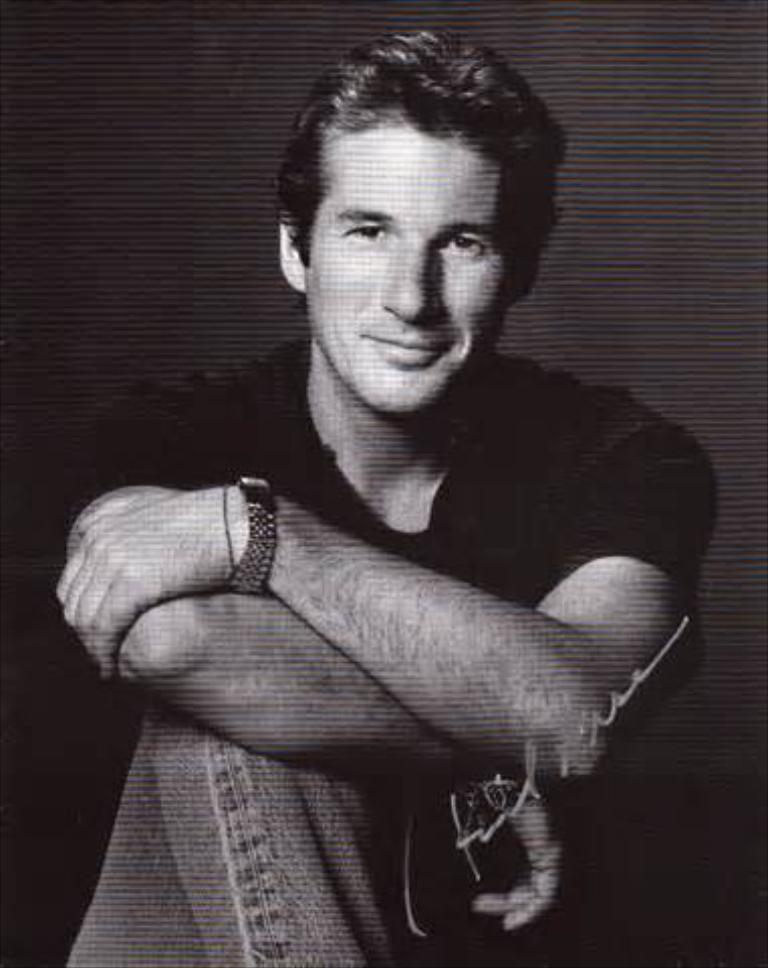What is the man in the image doing? The man is sitting in the image. What else can be seen on the image besides the man? There is text on the image. What color is the background of the image? The background of the image is black. What type of juice is the man holding in the image? There is no juice present in the image; the man is simply sitting. Is the man wearing a crown in the image? There is no crown visible in the image. 